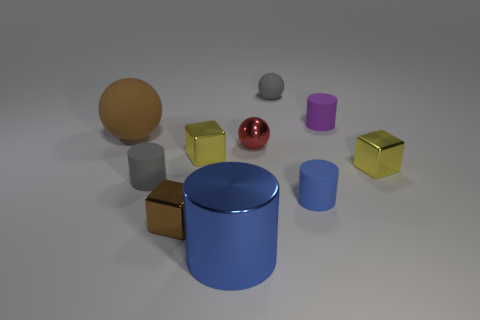Subtract all balls. How many objects are left? 7 Add 3 small gray things. How many small gray things are left? 5 Add 4 tiny red balls. How many tiny red balls exist? 5 Subtract 0 gray blocks. How many objects are left? 10 Subtract all purple things. Subtract all large blue metal things. How many objects are left? 8 